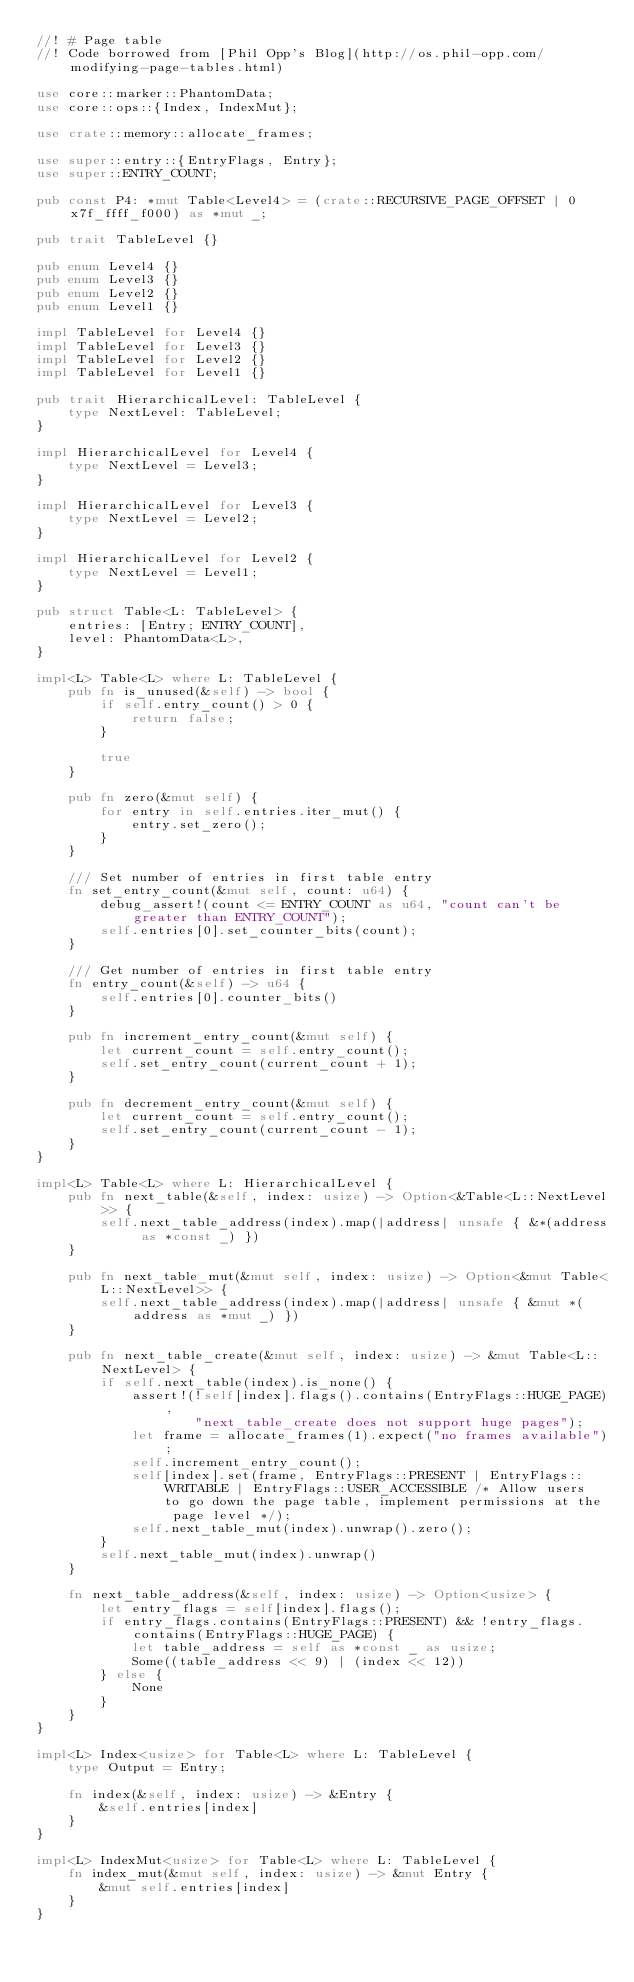Convert code to text. <code><loc_0><loc_0><loc_500><loc_500><_Rust_>//! # Page table
//! Code borrowed from [Phil Opp's Blog](http://os.phil-opp.com/modifying-page-tables.html)

use core::marker::PhantomData;
use core::ops::{Index, IndexMut};

use crate::memory::allocate_frames;

use super::entry::{EntryFlags, Entry};
use super::ENTRY_COUNT;

pub const P4: *mut Table<Level4> = (crate::RECURSIVE_PAGE_OFFSET | 0x7f_ffff_f000) as *mut _;

pub trait TableLevel {}

pub enum Level4 {}
pub enum Level3 {}
pub enum Level2 {}
pub enum Level1 {}

impl TableLevel for Level4 {}
impl TableLevel for Level3 {}
impl TableLevel for Level2 {}
impl TableLevel for Level1 {}

pub trait HierarchicalLevel: TableLevel {
    type NextLevel: TableLevel;
}

impl HierarchicalLevel for Level4 {
    type NextLevel = Level3;
}

impl HierarchicalLevel for Level3 {
    type NextLevel = Level2;
}

impl HierarchicalLevel for Level2 {
    type NextLevel = Level1;
}

pub struct Table<L: TableLevel> {
    entries: [Entry; ENTRY_COUNT],
    level: PhantomData<L>,
}

impl<L> Table<L> where L: TableLevel {
    pub fn is_unused(&self) -> bool {
        if self.entry_count() > 0 {
            return false;
        }

        true
    }

    pub fn zero(&mut self) {
        for entry in self.entries.iter_mut() {
            entry.set_zero();
        }
    }

    /// Set number of entries in first table entry
    fn set_entry_count(&mut self, count: u64) {
        debug_assert!(count <= ENTRY_COUNT as u64, "count can't be greater than ENTRY_COUNT");
        self.entries[0].set_counter_bits(count);
    }

    /// Get number of entries in first table entry
    fn entry_count(&self) -> u64 {
        self.entries[0].counter_bits()
    }

    pub fn increment_entry_count(&mut self) {
        let current_count = self.entry_count();
        self.set_entry_count(current_count + 1);
    }

    pub fn decrement_entry_count(&mut self) {
        let current_count = self.entry_count();
        self.set_entry_count(current_count - 1);
    }
}

impl<L> Table<L> where L: HierarchicalLevel {
    pub fn next_table(&self, index: usize) -> Option<&Table<L::NextLevel>> {
        self.next_table_address(index).map(|address| unsafe { &*(address as *const _) })
    }

    pub fn next_table_mut(&mut self, index: usize) -> Option<&mut Table<L::NextLevel>> {
        self.next_table_address(index).map(|address| unsafe { &mut *(address as *mut _) })
    }

    pub fn next_table_create(&mut self, index: usize) -> &mut Table<L::NextLevel> {
        if self.next_table(index).is_none() {
            assert!(!self[index].flags().contains(EntryFlags::HUGE_PAGE),
                    "next_table_create does not support huge pages");
            let frame = allocate_frames(1).expect("no frames available");
            self.increment_entry_count();
            self[index].set(frame, EntryFlags::PRESENT | EntryFlags::WRITABLE | EntryFlags::USER_ACCESSIBLE /* Allow users to go down the page table, implement permissions at the page level */);
            self.next_table_mut(index).unwrap().zero();
        }
        self.next_table_mut(index).unwrap()
    }

    fn next_table_address(&self, index: usize) -> Option<usize> {
        let entry_flags = self[index].flags();
        if entry_flags.contains(EntryFlags::PRESENT) && !entry_flags.contains(EntryFlags::HUGE_PAGE) {
            let table_address = self as *const _ as usize;
            Some((table_address << 9) | (index << 12))
        } else {
            None
        }
    }
}

impl<L> Index<usize> for Table<L> where L: TableLevel {
    type Output = Entry;

    fn index(&self, index: usize) -> &Entry {
        &self.entries[index]
    }
}

impl<L> IndexMut<usize> for Table<L> where L: TableLevel {
    fn index_mut(&mut self, index: usize) -> &mut Entry {
        &mut self.entries[index]
    }
}
</code> 